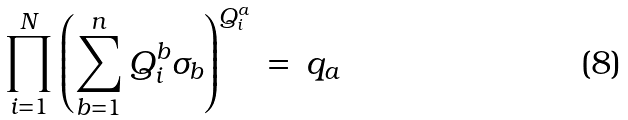Convert formula to latex. <formula><loc_0><loc_0><loc_500><loc_500>\prod _ { i = 1 } ^ { N } \left ( \sum _ { b = 1 } ^ { n } Q _ { i } ^ { b } \sigma _ { b } \right ) ^ { Q _ { i } ^ { a } } \, = \, q _ { a }</formula> 